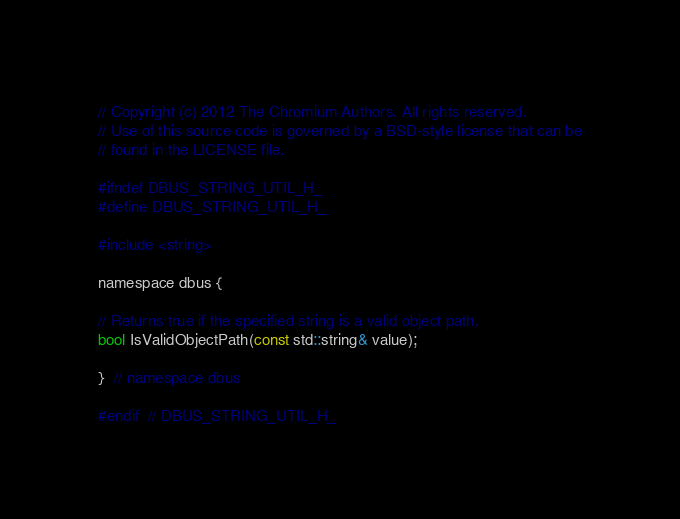Convert code to text. <code><loc_0><loc_0><loc_500><loc_500><_C_>// Copyright (c) 2012 The Chromium Authors. All rights reserved.
// Use of this source code is governed by a BSD-style license that can be
// found in the LICENSE file.

#ifndef DBUS_STRING_UTIL_H_
#define DBUS_STRING_UTIL_H_

#include <string>

namespace dbus {

// Returns true if the specified string is a valid object path.
bool IsValidObjectPath(const std::string& value);

}  // namespace dbus

#endif  // DBUS_STRING_UTIL_H_
</code> 